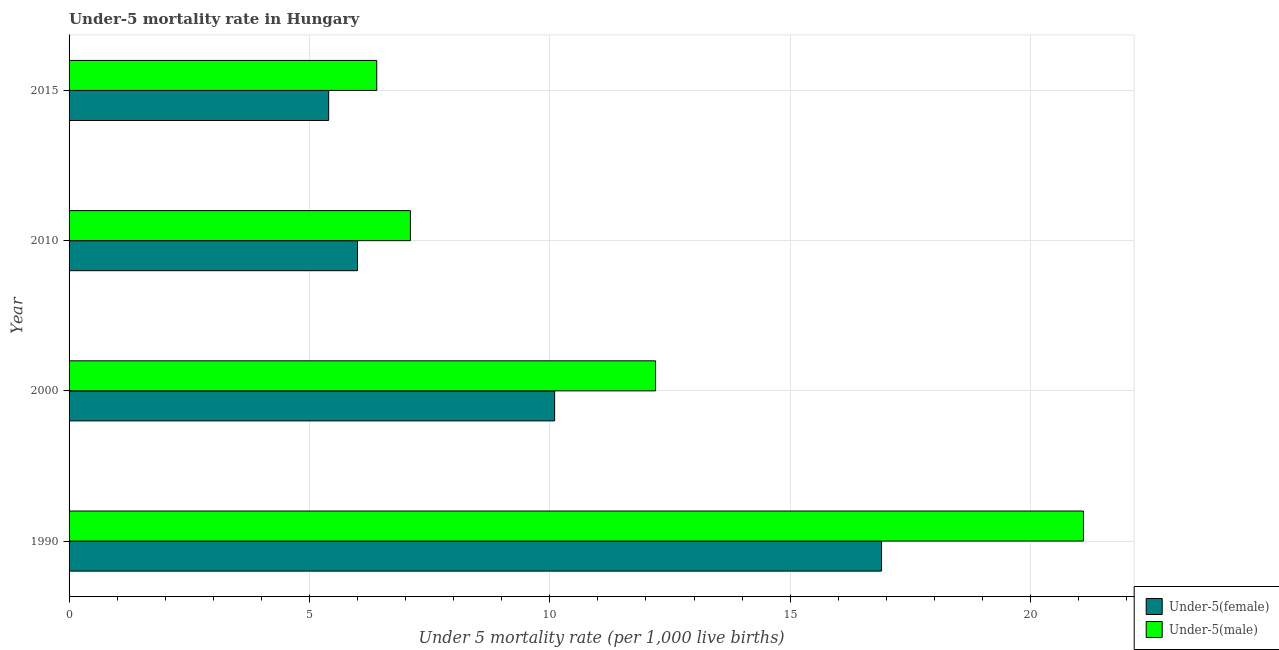How many different coloured bars are there?
Offer a very short reply. 2. How many bars are there on the 3rd tick from the bottom?
Make the answer very short. 2. In how many cases, is the number of bars for a given year not equal to the number of legend labels?
Provide a short and direct response. 0. What is the under-5 female mortality rate in 1990?
Ensure brevity in your answer.  16.9. Across all years, what is the maximum under-5 male mortality rate?
Provide a succinct answer. 21.1. In which year was the under-5 female mortality rate minimum?
Your answer should be very brief. 2015. What is the total under-5 female mortality rate in the graph?
Your response must be concise. 38.4. What is the difference between the under-5 female mortality rate in 2010 and the under-5 male mortality rate in 2015?
Your response must be concise. -0.4. What is the average under-5 female mortality rate per year?
Give a very brief answer. 9.6. In how many years, is the under-5 male mortality rate greater than 19 ?
Provide a short and direct response. 1. What is the ratio of the under-5 male mortality rate in 2010 to that in 2015?
Offer a terse response. 1.11. Is the difference between the under-5 female mortality rate in 1990 and 2010 greater than the difference between the under-5 male mortality rate in 1990 and 2010?
Your answer should be compact. No. What is the difference between the highest and the second highest under-5 male mortality rate?
Make the answer very short. 8.9. What is the difference between the highest and the lowest under-5 male mortality rate?
Offer a terse response. 14.7. What does the 2nd bar from the top in 2015 represents?
Ensure brevity in your answer.  Under-5(female). What does the 1st bar from the bottom in 2000 represents?
Provide a succinct answer. Under-5(female). How many bars are there?
Your response must be concise. 8. Are all the bars in the graph horizontal?
Provide a succinct answer. Yes. How many years are there in the graph?
Provide a short and direct response. 4. Are the values on the major ticks of X-axis written in scientific E-notation?
Keep it short and to the point. No. Where does the legend appear in the graph?
Keep it short and to the point. Bottom right. How many legend labels are there?
Provide a short and direct response. 2. What is the title of the graph?
Make the answer very short. Under-5 mortality rate in Hungary. Does "National Visitors" appear as one of the legend labels in the graph?
Ensure brevity in your answer.  No. What is the label or title of the X-axis?
Offer a very short reply. Under 5 mortality rate (per 1,0 live births). What is the Under 5 mortality rate (per 1,000 live births) in Under-5(female) in 1990?
Your response must be concise. 16.9. What is the Under 5 mortality rate (per 1,000 live births) in Under-5(male) in 1990?
Your response must be concise. 21.1. What is the Under 5 mortality rate (per 1,000 live births) in Under-5(female) in 2000?
Make the answer very short. 10.1. What is the Under 5 mortality rate (per 1,000 live births) of Under-5(male) in 2015?
Provide a short and direct response. 6.4. Across all years, what is the maximum Under 5 mortality rate (per 1,000 live births) in Under-5(female)?
Your answer should be compact. 16.9. Across all years, what is the maximum Under 5 mortality rate (per 1,000 live births) of Under-5(male)?
Provide a succinct answer. 21.1. What is the total Under 5 mortality rate (per 1,000 live births) of Under-5(female) in the graph?
Keep it short and to the point. 38.4. What is the total Under 5 mortality rate (per 1,000 live births) in Under-5(male) in the graph?
Your answer should be very brief. 46.8. What is the difference between the Under 5 mortality rate (per 1,000 live births) of Under-5(male) in 1990 and that in 2000?
Ensure brevity in your answer.  8.9. What is the difference between the Under 5 mortality rate (per 1,000 live births) in Under-5(male) in 1990 and that in 2010?
Give a very brief answer. 14. What is the difference between the Under 5 mortality rate (per 1,000 live births) of Under-5(female) in 1990 and that in 2015?
Give a very brief answer. 11.5. What is the difference between the Under 5 mortality rate (per 1,000 live births) of Under-5(male) in 1990 and that in 2015?
Provide a short and direct response. 14.7. What is the difference between the Under 5 mortality rate (per 1,000 live births) in Under-5(female) in 2000 and that in 2010?
Give a very brief answer. 4.1. What is the difference between the Under 5 mortality rate (per 1,000 live births) in Under-5(male) in 2000 and that in 2010?
Keep it short and to the point. 5.1. What is the difference between the Under 5 mortality rate (per 1,000 live births) of Under-5(female) in 2000 and that in 2015?
Your response must be concise. 4.7. What is the difference between the Under 5 mortality rate (per 1,000 live births) of Under-5(male) in 2000 and that in 2015?
Give a very brief answer. 5.8. What is the difference between the Under 5 mortality rate (per 1,000 live births) in Under-5(male) in 2010 and that in 2015?
Your answer should be compact. 0.7. What is the difference between the Under 5 mortality rate (per 1,000 live births) of Under-5(female) in 1990 and the Under 5 mortality rate (per 1,000 live births) of Under-5(male) in 2000?
Ensure brevity in your answer.  4.7. What is the difference between the Under 5 mortality rate (per 1,000 live births) of Under-5(female) in 2000 and the Under 5 mortality rate (per 1,000 live births) of Under-5(male) in 2010?
Your response must be concise. 3. What is the difference between the Under 5 mortality rate (per 1,000 live births) of Under-5(female) in 2010 and the Under 5 mortality rate (per 1,000 live births) of Under-5(male) in 2015?
Your answer should be compact. -0.4. What is the average Under 5 mortality rate (per 1,000 live births) of Under-5(female) per year?
Ensure brevity in your answer.  9.6. What is the average Under 5 mortality rate (per 1,000 live births) in Under-5(male) per year?
Your answer should be very brief. 11.7. What is the ratio of the Under 5 mortality rate (per 1,000 live births) in Under-5(female) in 1990 to that in 2000?
Provide a short and direct response. 1.67. What is the ratio of the Under 5 mortality rate (per 1,000 live births) in Under-5(male) in 1990 to that in 2000?
Provide a succinct answer. 1.73. What is the ratio of the Under 5 mortality rate (per 1,000 live births) of Under-5(female) in 1990 to that in 2010?
Give a very brief answer. 2.82. What is the ratio of the Under 5 mortality rate (per 1,000 live births) in Under-5(male) in 1990 to that in 2010?
Your answer should be compact. 2.97. What is the ratio of the Under 5 mortality rate (per 1,000 live births) of Under-5(female) in 1990 to that in 2015?
Ensure brevity in your answer.  3.13. What is the ratio of the Under 5 mortality rate (per 1,000 live births) in Under-5(male) in 1990 to that in 2015?
Provide a succinct answer. 3.3. What is the ratio of the Under 5 mortality rate (per 1,000 live births) of Under-5(female) in 2000 to that in 2010?
Offer a terse response. 1.68. What is the ratio of the Under 5 mortality rate (per 1,000 live births) of Under-5(male) in 2000 to that in 2010?
Your answer should be compact. 1.72. What is the ratio of the Under 5 mortality rate (per 1,000 live births) in Under-5(female) in 2000 to that in 2015?
Your answer should be very brief. 1.87. What is the ratio of the Under 5 mortality rate (per 1,000 live births) of Under-5(male) in 2000 to that in 2015?
Provide a short and direct response. 1.91. What is the ratio of the Under 5 mortality rate (per 1,000 live births) of Under-5(female) in 2010 to that in 2015?
Provide a succinct answer. 1.11. What is the ratio of the Under 5 mortality rate (per 1,000 live births) in Under-5(male) in 2010 to that in 2015?
Ensure brevity in your answer.  1.11. What is the difference between the highest and the second highest Under 5 mortality rate (per 1,000 live births) in Under-5(male)?
Give a very brief answer. 8.9. What is the difference between the highest and the lowest Under 5 mortality rate (per 1,000 live births) in Under-5(female)?
Provide a succinct answer. 11.5. What is the difference between the highest and the lowest Under 5 mortality rate (per 1,000 live births) in Under-5(male)?
Give a very brief answer. 14.7. 